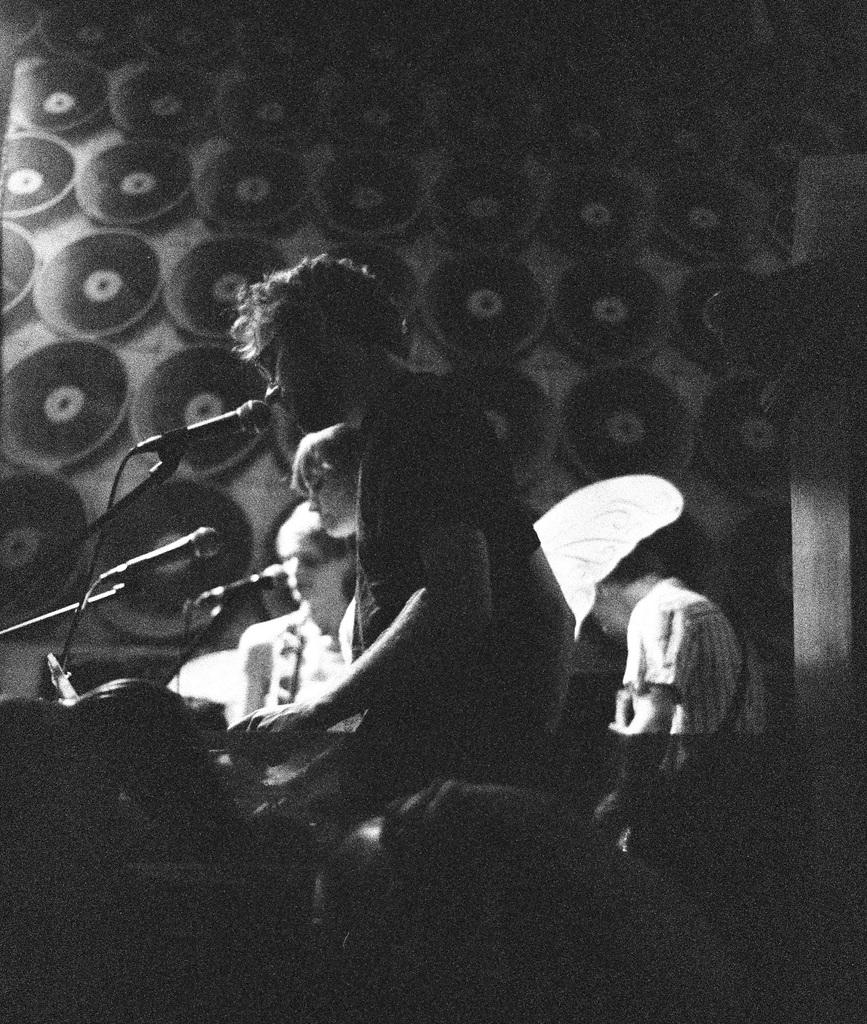Who or what is present in the image? There are people in the image. What objects are placed before the people? Microphones are placed before the people. What can be seen at the bottom of the image? There is a band at the bottom of the image. What is visible in the background of the image? There is a wall in the background of the image. What type of dress is the owner of the microphones wearing in the image? There is no owner of the microphones mentioned in the image, and no one is wearing a dress. 